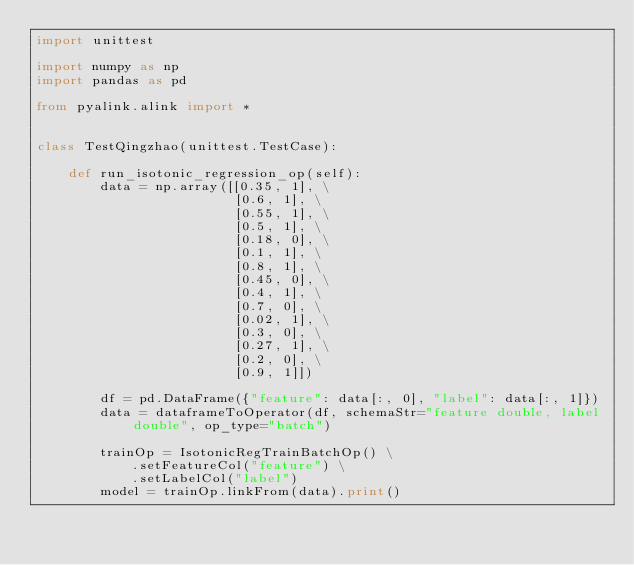Convert code to text. <code><loc_0><loc_0><loc_500><loc_500><_Python_>import unittest

import numpy as np
import pandas as pd

from pyalink.alink import *


class TestQingzhao(unittest.TestCase):

    def run_isotonic_regression_op(self):
        data = np.array([[0.35, 1], \
                         [0.6, 1], \
                         [0.55, 1], \
                         [0.5, 1], \
                         [0.18, 0], \
                         [0.1, 1], \
                         [0.8, 1], \
                         [0.45, 0], \
                         [0.4, 1], \
                         [0.7, 0], \
                         [0.02, 1], \
                         [0.3, 0], \
                         [0.27, 1], \
                         [0.2, 0], \
                         [0.9, 1]])

        df = pd.DataFrame({"feature": data[:, 0], "label": data[:, 1]})
        data = dataframeToOperator(df, schemaStr="feature double, label double", op_type="batch")

        trainOp = IsotonicRegTrainBatchOp() \
            .setFeatureCol("feature") \
            .setLabelCol("label")
        model = trainOp.linkFrom(data).print()
</code> 